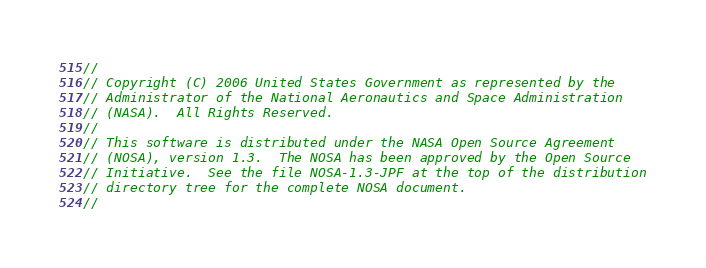Convert code to text. <code><loc_0><loc_0><loc_500><loc_500><_Java_>//
// Copyright (C) 2006 United States Government as represented by the
// Administrator of the National Aeronautics and Space Administration
// (NASA).  All Rights Reserved.
// 
// This software is distributed under the NASA Open Source Agreement
// (NOSA), version 1.3.  The NOSA has been approved by the Open Source
// Initiative.  See the file NOSA-1.3-JPF at the top of the distribution
// directory tree for the complete NOSA document.
// </code> 